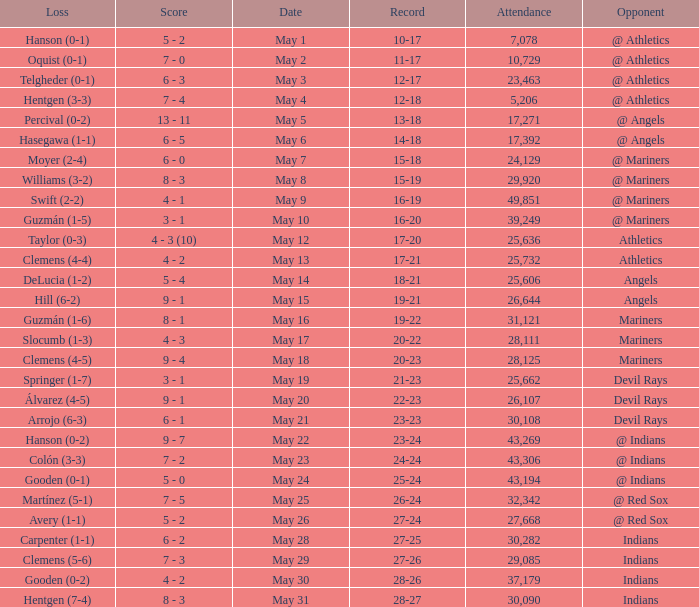For record 25-24, what is the aggregate of attendees? 1.0. 